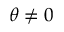<formula> <loc_0><loc_0><loc_500><loc_500>\theta \neq 0</formula> 